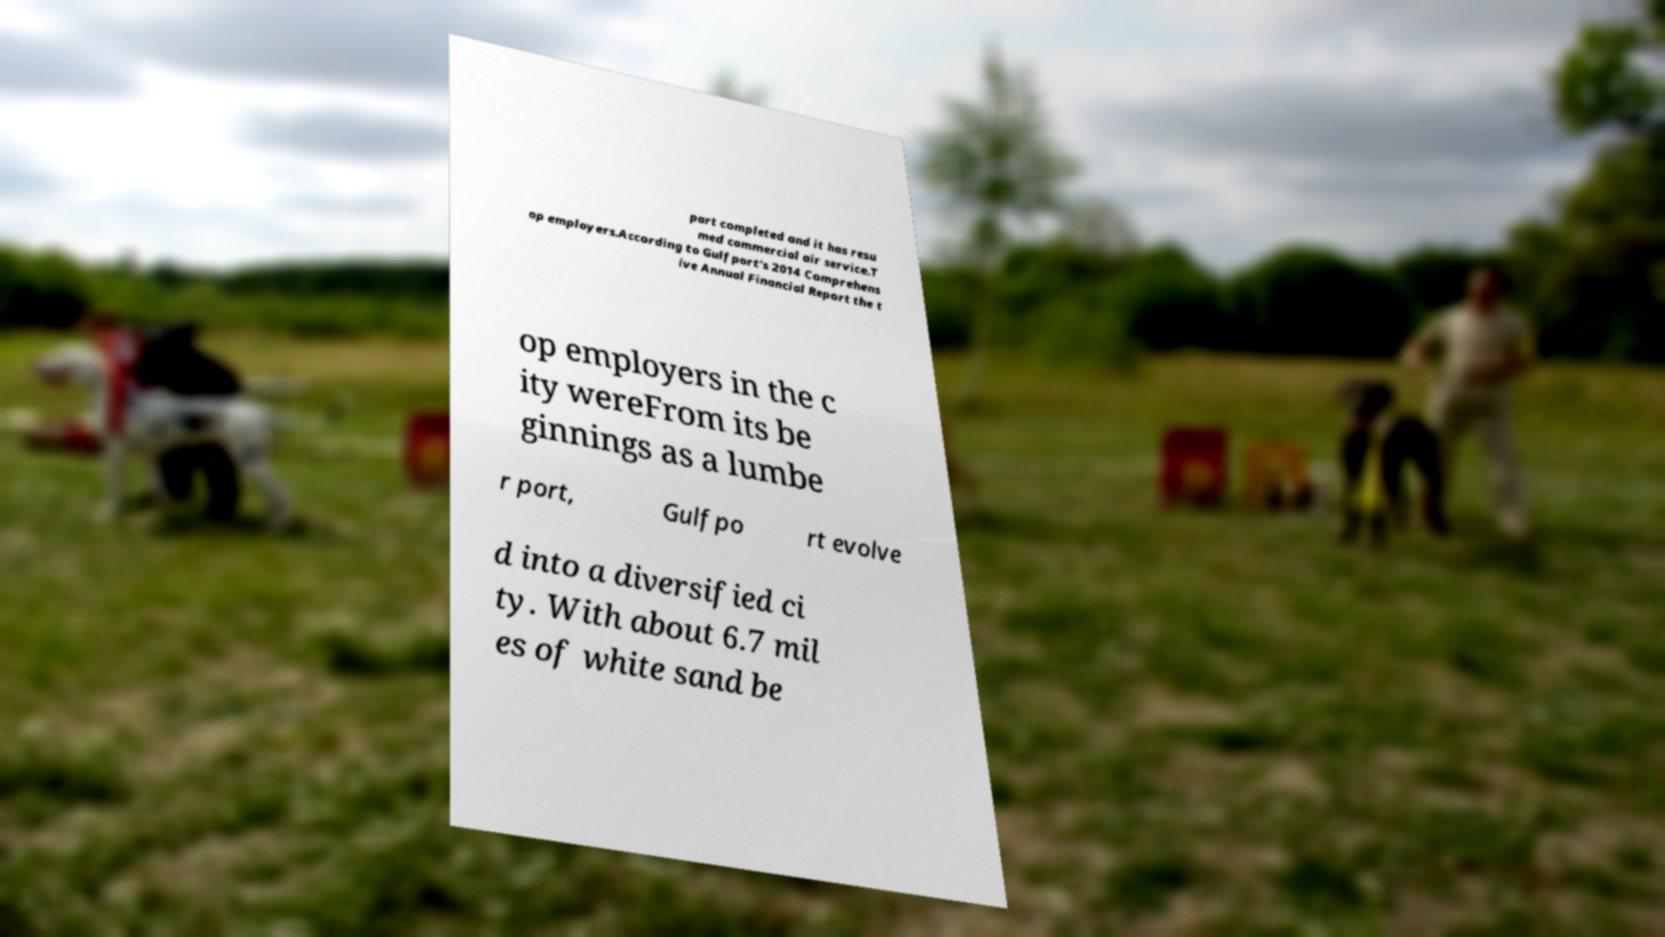Could you assist in decoding the text presented in this image and type it out clearly? part completed and it has resu med commercial air service.T op employers.According to Gulfport's 2014 Comprehens ive Annual Financial Report the t op employers in the c ity wereFrom its be ginnings as a lumbe r port, Gulfpo rt evolve d into a diversified ci ty. With about 6.7 mil es of white sand be 